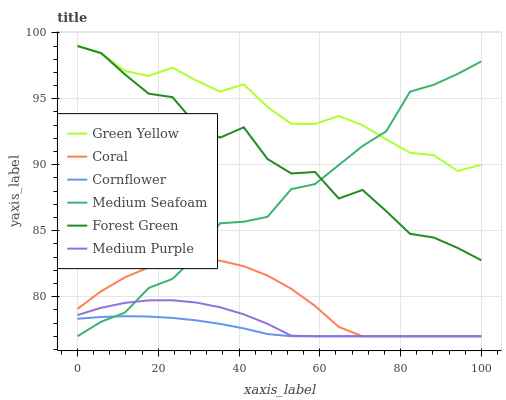Does Coral have the minimum area under the curve?
Answer yes or no. No. Does Coral have the maximum area under the curve?
Answer yes or no. No. Is Coral the smoothest?
Answer yes or no. No. Is Coral the roughest?
Answer yes or no. No. Does Forest Green have the lowest value?
Answer yes or no. No. Does Coral have the highest value?
Answer yes or no. No. Is Coral less than Green Yellow?
Answer yes or no. Yes. Is Forest Green greater than Medium Purple?
Answer yes or no. Yes. Does Coral intersect Green Yellow?
Answer yes or no. No. 